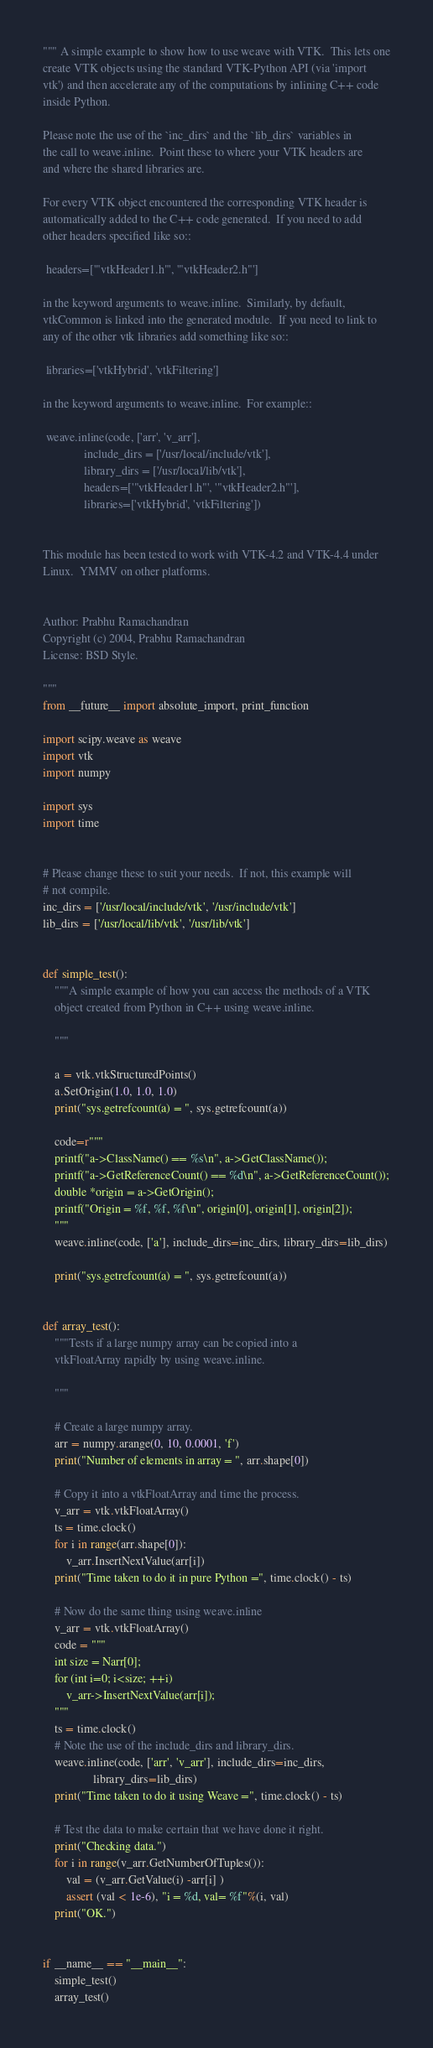Convert code to text. <code><loc_0><loc_0><loc_500><loc_500><_Python_>""" A simple example to show how to use weave with VTK.  This lets one
create VTK objects using the standard VTK-Python API (via 'import
vtk') and then accelerate any of the computations by inlining C++ code
inside Python.

Please note the use of the `inc_dirs` and the `lib_dirs` variables in
the call to weave.inline.  Point these to where your VTK headers are
and where the shared libraries are.

For every VTK object encountered the corresponding VTK header is
automatically added to the C++ code generated.  If you need to add
other headers specified like so::

 headers=['"vtkHeader1.h"', '"vtkHeader2.h"']

in the keyword arguments to weave.inline.  Similarly, by default,
vtkCommon is linked into the generated module.  If you need to link to
any of the other vtk libraries add something like so::

 libraries=['vtkHybrid', 'vtkFiltering']

in the keyword arguments to weave.inline.  For example::

 weave.inline(code, ['arr', 'v_arr'],
              include_dirs = ['/usr/local/include/vtk'],
              library_dirs = ['/usr/local/lib/vtk'],
              headers=['"vtkHeader1.h"', '"vtkHeader2.h"'],
              libraries=['vtkHybrid', 'vtkFiltering'])


This module has been tested to work with VTK-4.2 and VTK-4.4 under
Linux.  YMMV on other platforms.


Author: Prabhu Ramachandran
Copyright (c) 2004, Prabhu Ramachandran
License: BSD Style.

"""
from __future__ import absolute_import, print_function

import scipy.weave as weave
import vtk
import numpy

import sys
import time


# Please change these to suit your needs.  If not, this example will
# not compile.
inc_dirs = ['/usr/local/include/vtk', '/usr/include/vtk']
lib_dirs = ['/usr/local/lib/vtk', '/usr/lib/vtk']


def simple_test():
    """A simple example of how you can access the methods of a VTK
    object created from Python in C++ using weave.inline.

    """

    a = vtk.vtkStructuredPoints()
    a.SetOrigin(1.0, 1.0, 1.0)
    print("sys.getrefcount(a) = ", sys.getrefcount(a))

    code=r"""
    printf("a->ClassName() == %s\n", a->GetClassName());
    printf("a->GetReferenceCount() == %d\n", a->GetReferenceCount());
    double *origin = a->GetOrigin();
    printf("Origin = %f, %f, %f\n", origin[0], origin[1], origin[2]);
    """
    weave.inline(code, ['a'], include_dirs=inc_dirs, library_dirs=lib_dirs)

    print("sys.getrefcount(a) = ", sys.getrefcount(a))


def array_test():
    """Tests if a large numpy array can be copied into a
    vtkFloatArray rapidly by using weave.inline.

    """

    # Create a large numpy array.
    arr = numpy.arange(0, 10, 0.0001, 'f')
    print("Number of elements in array = ", arr.shape[0])

    # Copy it into a vtkFloatArray and time the process.
    v_arr = vtk.vtkFloatArray()
    ts = time.clock()
    for i in range(arr.shape[0]):
        v_arr.InsertNextValue(arr[i])
    print("Time taken to do it in pure Python =", time.clock() - ts)

    # Now do the same thing using weave.inline
    v_arr = vtk.vtkFloatArray()
    code = """
    int size = Narr[0];
    for (int i=0; i<size; ++i)
        v_arr->InsertNextValue(arr[i]);
    """
    ts = time.clock()
    # Note the use of the include_dirs and library_dirs.
    weave.inline(code, ['arr', 'v_arr'], include_dirs=inc_dirs,
                 library_dirs=lib_dirs)
    print("Time taken to do it using Weave =", time.clock() - ts)

    # Test the data to make certain that we have done it right.
    print("Checking data.")
    for i in range(v_arr.GetNumberOfTuples()):
        val = (v_arr.GetValue(i) -arr[i] )
        assert (val < 1e-6), "i = %d, val= %f"%(i, val)
    print("OK.")


if __name__ == "__main__":
    simple_test()
    array_test()
</code> 